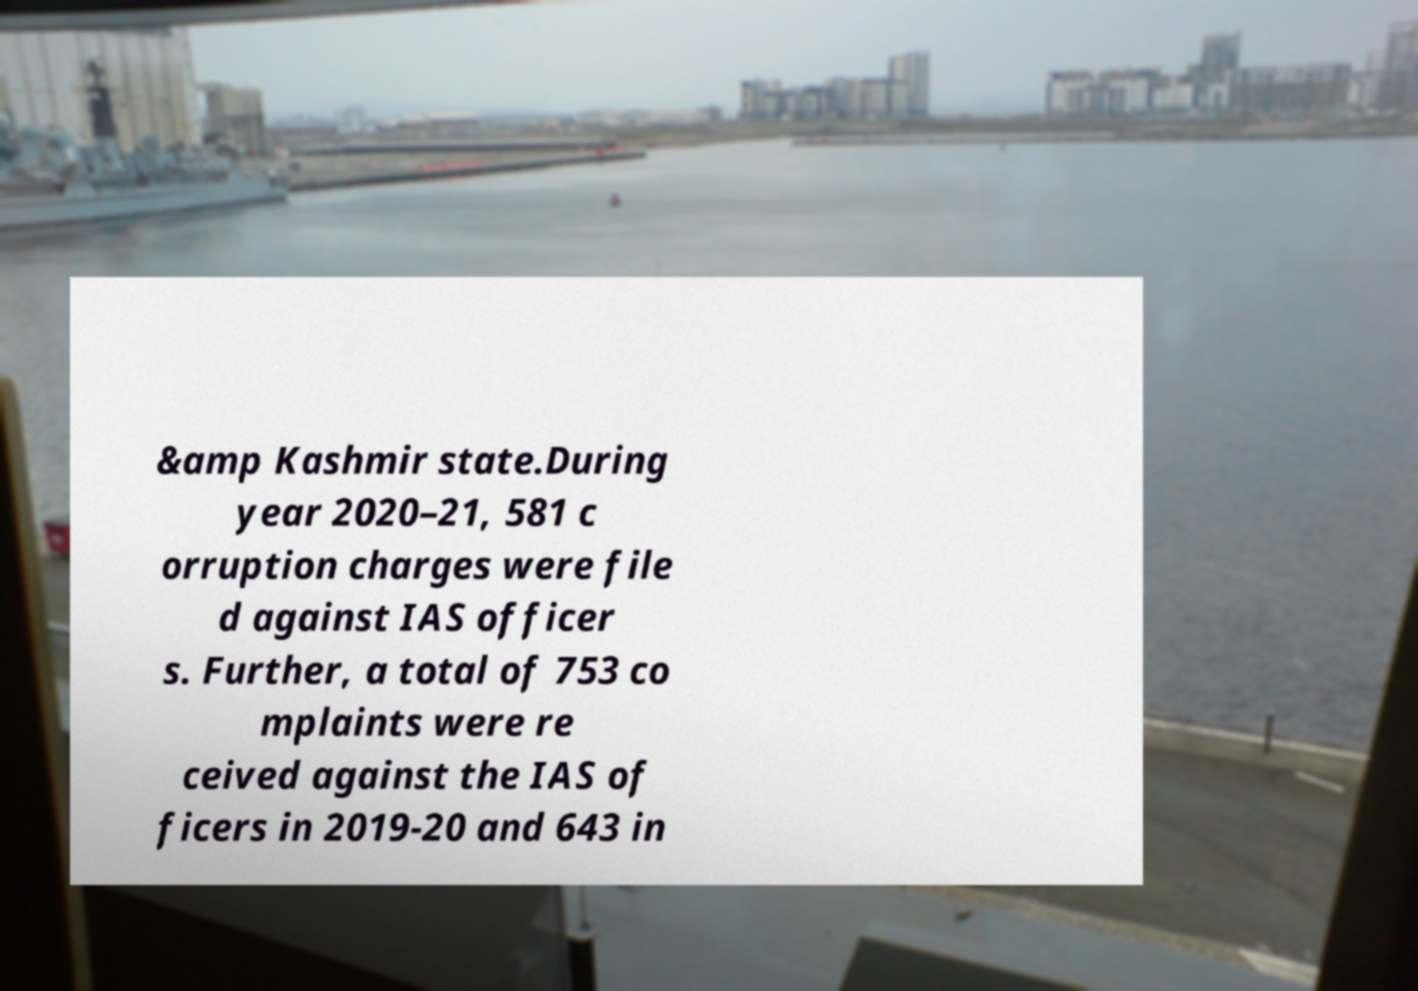I need the written content from this picture converted into text. Can you do that? &amp Kashmir state.During year 2020–21, 581 c orruption charges were file d against IAS officer s. Further, a total of 753 co mplaints were re ceived against the IAS of ficers in 2019-20 and 643 in 